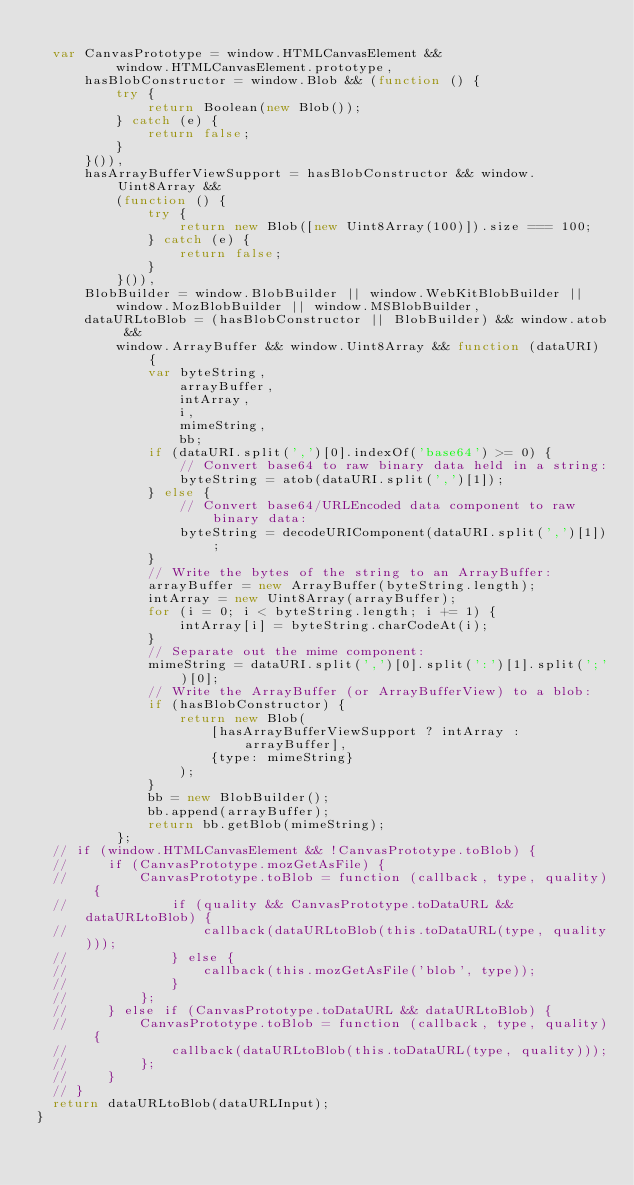Convert code to text. <code><loc_0><loc_0><loc_500><loc_500><_JavaScript_>
	var CanvasPrototype = window.HTMLCanvasElement &&
	        window.HTMLCanvasElement.prototype,
	    hasBlobConstructor = window.Blob && (function () {
	        try {
	            return Boolean(new Blob());
	        } catch (e) {
	            return false;
	        }
	    }()),
	    hasArrayBufferViewSupport = hasBlobConstructor && window.Uint8Array &&
	        (function () {
	            try {
	                return new Blob([new Uint8Array(100)]).size === 100;
	            } catch (e) {
	                return false;
	            }
	        }()),
	    BlobBuilder = window.BlobBuilder || window.WebKitBlobBuilder ||
	        window.MozBlobBuilder || window.MSBlobBuilder,
	    dataURLtoBlob = (hasBlobConstructor || BlobBuilder) && window.atob &&
	        window.ArrayBuffer && window.Uint8Array && function (dataURI) {
	            var byteString,
	                arrayBuffer,
	                intArray,
	                i,
	                mimeString,
	                bb;
	            if (dataURI.split(',')[0].indexOf('base64') >= 0) {
	                // Convert base64 to raw binary data held in a string:
	                byteString = atob(dataURI.split(',')[1]);
	            } else {
	                // Convert base64/URLEncoded data component to raw binary data:
	                byteString = decodeURIComponent(dataURI.split(',')[1]);
	            }
	            // Write the bytes of the string to an ArrayBuffer:
	            arrayBuffer = new ArrayBuffer(byteString.length);
	            intArray = new Uint8Array(arrayBuffer);
	            for (i = 0; i < byteString.length; i += 1) {
	                intArray[i] = byteString.charCodeAt(i);
	            }
	            // Separate out the mime component:
	            mimeString = dataURI.split(',')[0].split(':')[1].split(';')[0];
	            // Write the ArrayBuffer (or ArrayBufferView) to a blob:
	            if (hasBlobConstructor) {
	                return new Blob(
	                    [hasArrayBufferViewSupport ? intArray : arrayBuffer],
	                    {type: mimeString}
	                );
	            }
	            bb = new BlobBuilder();
	            bb.append(arrayBuffer);
	            return bb.getBlob(mimeString);
	        };
	// if (window.HTMLCanvasElement && !CanvasPrototype.toBlob) {
	//     if (CanvasPrototype.mozGetAsFile) {
	//         CanvasPrototype.toBlob = function (callback, type, quality) {
	//             if (quality && CanvasPrototype.toDataURL && dataURLtoBlob) {
	//                 callback(dataURLtoBlob(this.toDataURL(type, quality)));
	//             } else {
	//                 callback(this.mozGetAsFile('blob', type));
	//             }
	//         };
	//     } else if (CanvasPrototype.toDataURL && dataURLtoBlob) {
	//         CanvasPrototype.toBlob = function (callback, type, quality) {
	//             callback(dataURLtoBlob(this.toDataURL(type, quality)));
	//         };
	//     }
	// }
	return dataURLtoBlob(dataURLInput);	
}
</code> 